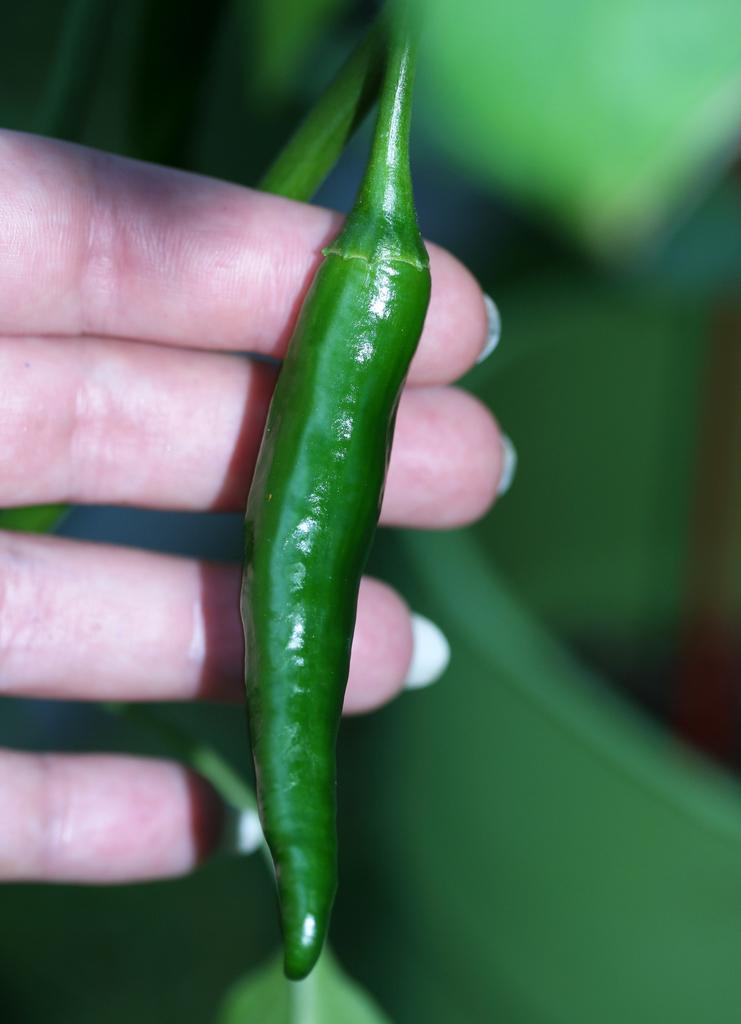Who or what is the main subject in the image? There is a person in the image. What is the person holding in the image? The person is holding green chilies. Can you describe the background of the image? The background of the image is green and blurred. What is the government's stance on the shocking event in the image? There is no mention of a shocking event or government in the image, as it only features a person holding green chilies with a green and blurred background. 